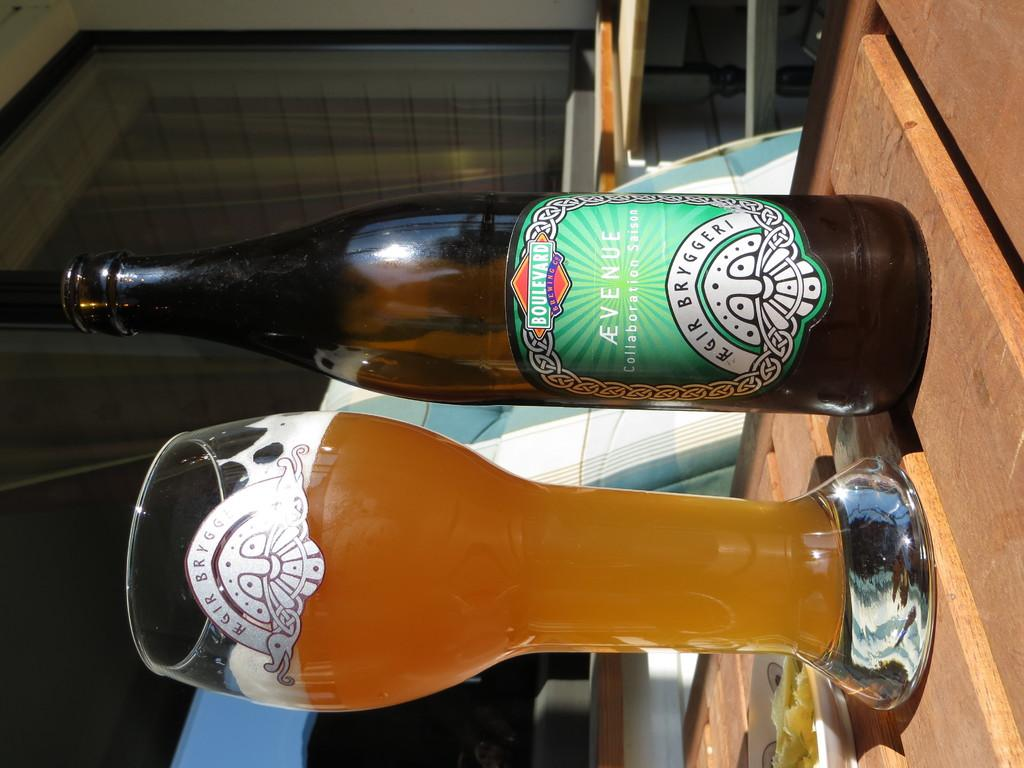<image>
Provide a brief description of the given image. A bottle of Ævenue Collaboration Saison is next to a glass of beer. 